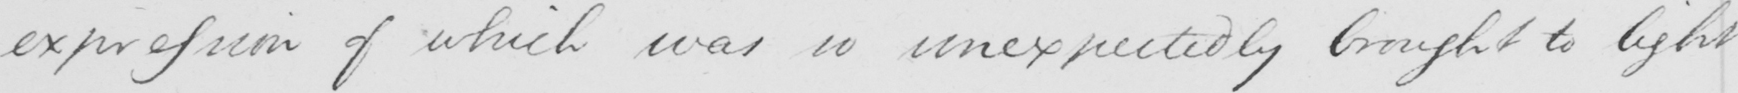What is written in this line of handwriting? expression of which was so unexpectedly brought to light 